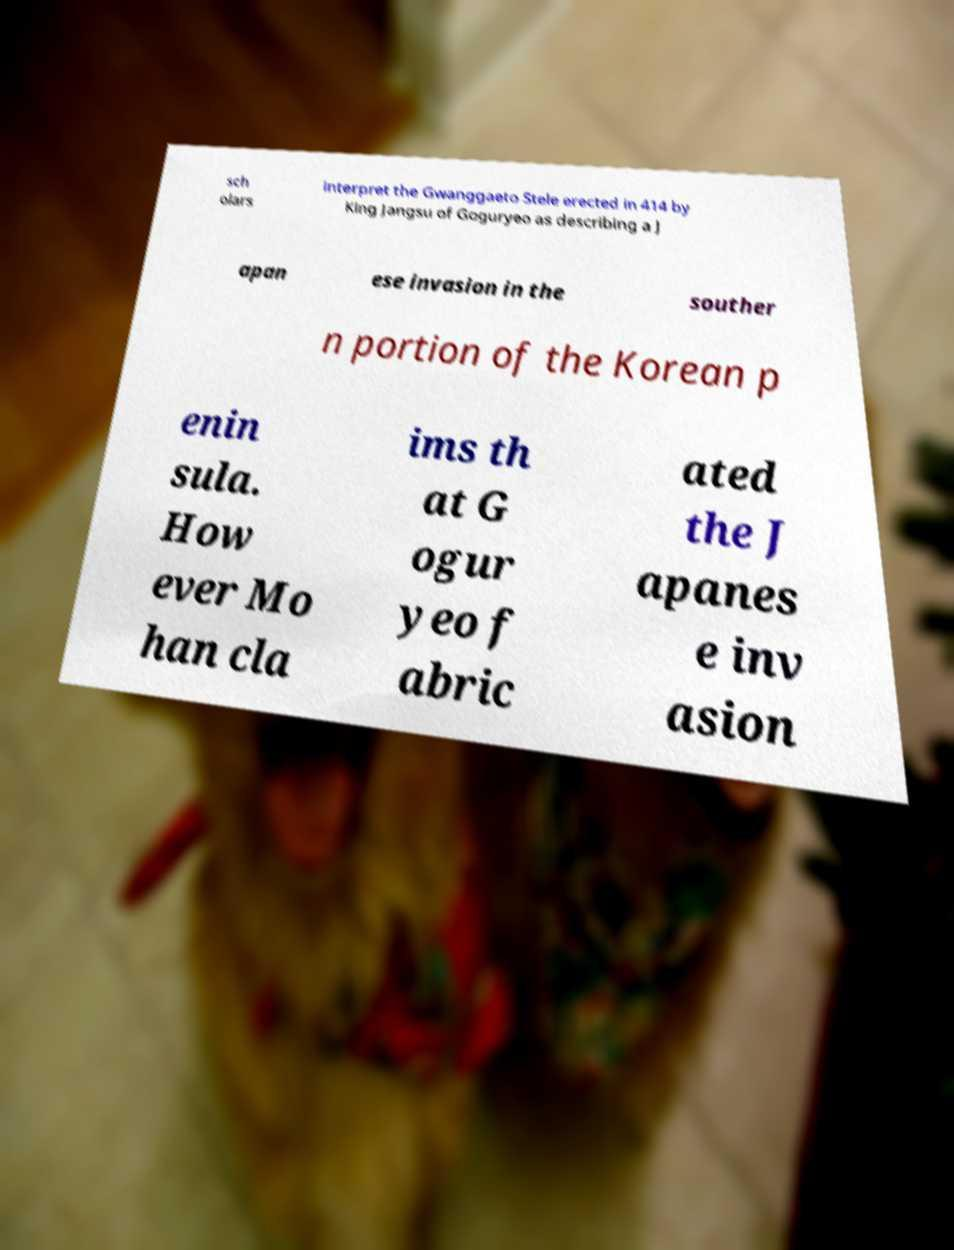Can you read and provide the text displayed in the image?This photo seems to have some interesting text. Can you extract and type it out for me? sch olars interpret the Gwanggaeto Stele erected in 414 by King Jangsu of Goguryeo as describing a J apan ese invasion in the souther n portion of the Korean p enin sula. How ever Mo han cla ims th at G ogur yeo f abric ated the J apanes e inv asion 